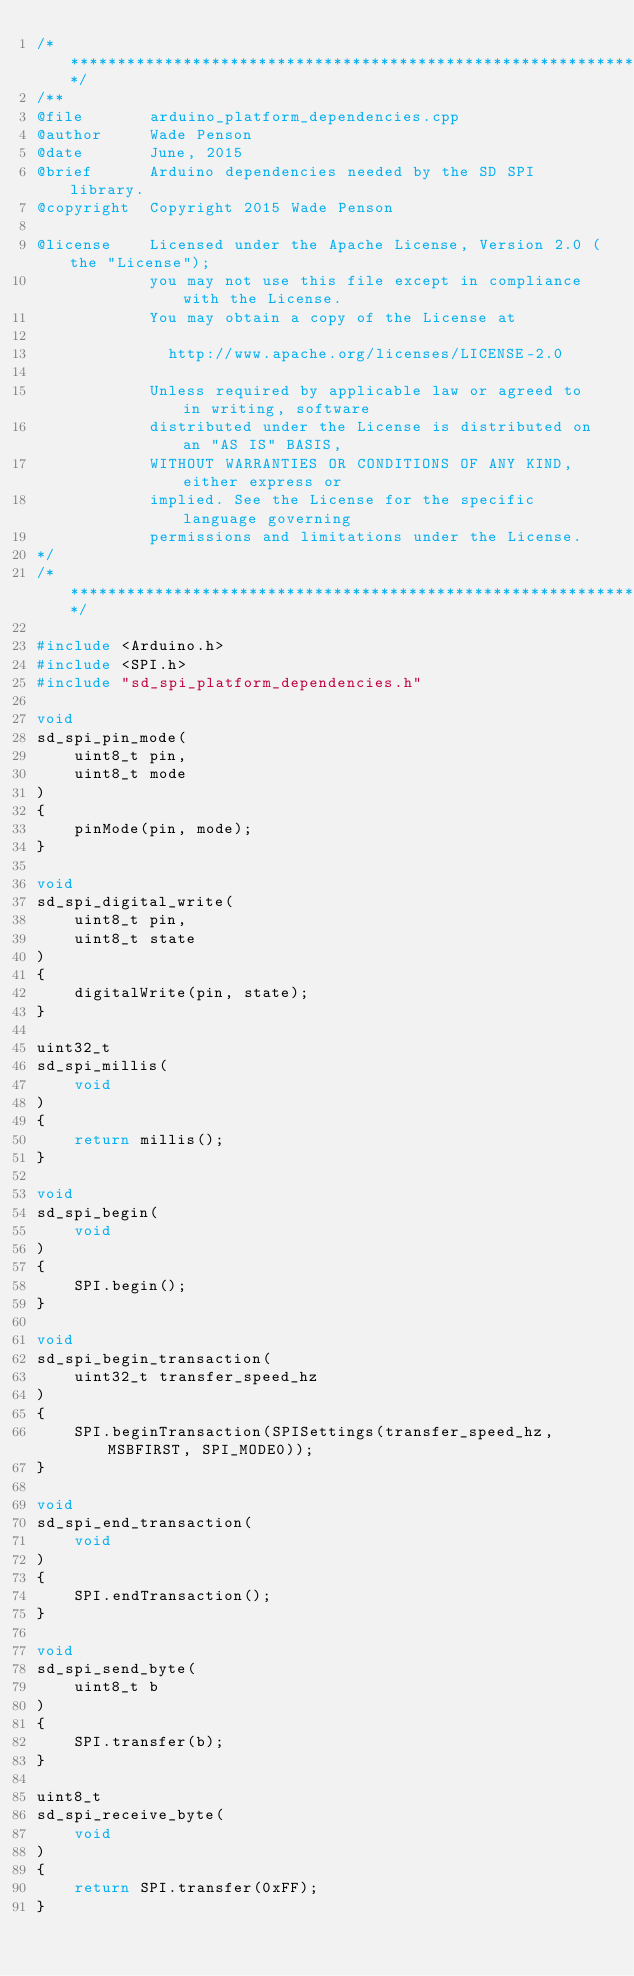Convert code to text. <code><loc_0><loc_0><loc_500><loc_500><_C++_>/******************************************************************************/
/**
@file		arduino_platform_dependencies.cpp
@author     Wade Penson
@date		June, 2015
@brief      Arduino dependencies needed by the SD SPI library.
@copyright  Copyright 2015 Wade Penson

@license    Licensed under the Apache License, Version 2.0 (the "License");
            you may not use this file except in compliance with the License.
            You may obtain a copy of the License at

              http://www.apache.org/licenses/LICENSE-2.0

            Unless required by applicable law or agreed to in writing, software
            distributed under the License is distributed on an "AS IS" BASIS,
            WITHOUT WARRANTIES OR CONDITIONS OF ANY KIND, either express or 
            implied. See the License for the specific language governing
            permissions and limitations under the License.
*/
/******************************************************************************/

#include <Arduino.h>
#include <SPI.h>
#include "sd_spi_platform_dependencies.h"

void
sd_spi_pin_mode(
	uint8_t pin,
	uint8_t mode
)
{
	pinMode(pin, mode);
}

void
sd_spi_digital_write(
	uint8_t pin,
	uint8_t state
)
{
	digitalWrite(pin, state);
}

uint32_t
sd_spi_millis(
	void
)
{
	return millis();
}

void
sd_spi_begin(
	void
)
{
	SPI.begin();
}

void
sd_spi_begin_transaction(
	uint32_t transfer_speed_hz
)
{
	SPI.beginTransaction(SPISettings(transfer_speed_hz, MSBFIRST, SPI_MODE0));
}

void
sd_spi_end_transaction(
	void
)
{
	SPI.endTransaction();
}

void
sd_spi_send_byte(
	uint8_t b
)
{
	SPI.transfer(b);
}

uint8_t
sd_spi_receive_byte(
	void
)
{
	return SPI.transfer(0xFF);
}</code> 